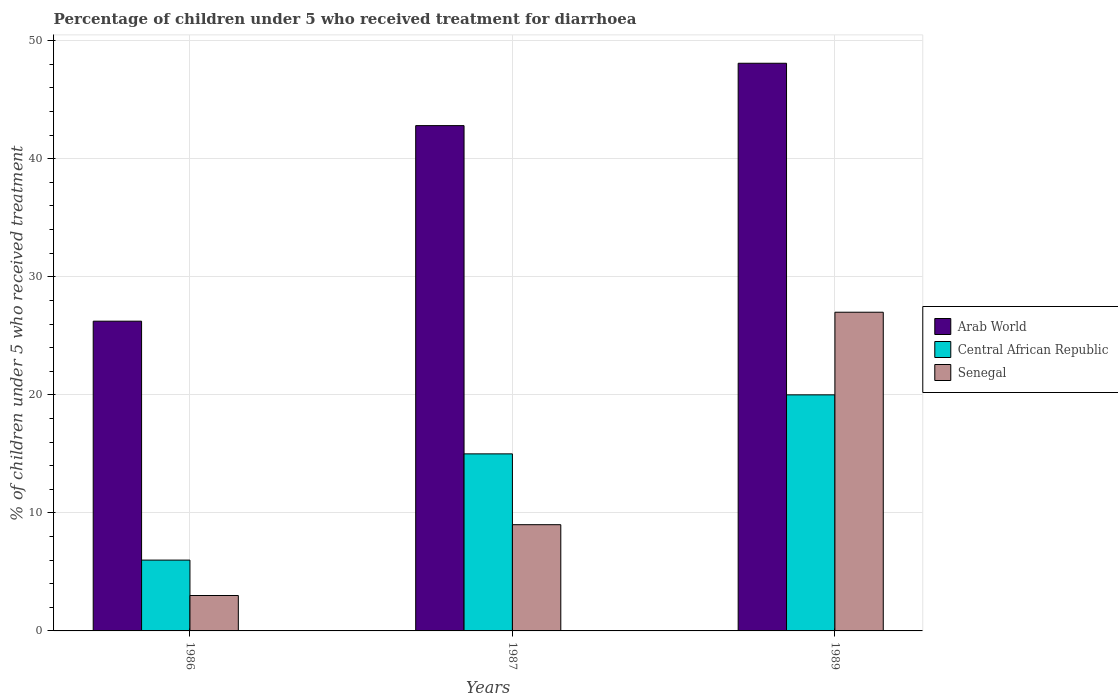How many groups of bars are there?
Offer a very short reply. 3. Are the number of bars per tick equal to the number of legend labels?
Your answer should be very brief. Yes. How many bars are there on the 3rd tick from the right?
Keep it short and to the point. 3. In how many cases, is the number of bars for a given year not equal to the number of legend labels?
Make the answer very short. 0. Across all years, what is the maximum percentage of children who received treatment for diarrhoea  in Central African Republic?
Provide a succinct answer. 20. Across all years, what is the minimum percentage of children who received treatment for diarrhoea  in Senegal?
Provide a succinct answer. 3. In which year was the percentage of children who received treatment for diarrhoea  in Central African Republic minimum?
Keep it short and to the point. 1986. What is the total percentage of children who received treatment for diarrhoea  in Arab World in the graph?
Provide a short and direct response. 117.14. What is the difference between the percentage of children who received treatment for diarrhoea  in Arab World in 1986 and the percentage of children who received treatment for diarrhoea  in Senegal in 1987?
Make the answer very short. 17.24. In the year 1989, what is the difference between the percentage of children who received treatment for diarrhoea  in Central African Republic and percentage of children who received treatment for diarrhoea  in Arab World?
Provide a succinct answer. -28.09. What is the ratio of the percentage of children who received treatment for diarrhoea  in Arab World in 1986 to that in 1987?
Your answer should be very brief. 0.61. Is the percentage of children who received treatment for diarrhoea  in Senegal in 1986 less than that in 1987?
Make the answer very short. Yes. What is the difference between the highest and the lowest percentage of children who received treatment for diarrhoea  in Senegal?
Your response must be concise. 24. Is the sum of the percentage of children who received treatment for diarrhoea  in Central African Republic in 1986 and 1989 greater than the maximum percentage of children who received treatment for diarrhoea  in Senegal across all years?
Provide a succinct answer. No. What does the 3rd bar from the left in 1987 represents?
Ensure brevity in your answer.  Senegal. What does the 2nd bar from the right in 1986 represents?
Make the answer very short. Central African Republic. Is it the case that in every year, the sum of the percentage of children who received treatment for diarrhoea  in Central African Republic and percentage of children who received treatment for diarrhoea  in Senegal is greater than the percentage of children who received treatment for diarrhoea  in Arab World?
Make the answer very short. No. How many bars are there?
Keep it short and to the point. 9. Are all the bars in the graph horizontal?
Provide a succinct answer. No. Are the values on the major ticks of Y-axis written in scientific E-notation?
Ensure brevity in your answer.  No. Does the graph contain grids?
Provide a succinct answer. Yes. Where does the legend appear in the graph?
Offer a terse response. Center right. How many legend labels are there?
Keep it short and to the point. 3. What is the title of the graph?
Offer a very short reply. Percentage of children under 5 who received treatment for diarrhoea. Does "Rwanda" appear as one of the legend labels in the graph?
Make the answer very short. No. What is the label or title of the Y-axis?
Offer a very short reply. % of children under 5 who received treatment. What is the % of children under 5 who received treatment of Arab World in 1986?
Offer a very short reply. 26.24. What is the % of children under 5 who received treatment of Arab World in 1987?
Provide a succinct answer. 42.81. What is the % of children under 5 who received treatment of Arab World in 1989?
Make the answer very short. 48.09. Across all years, what is the maximum % of children under 5 who received treatment in Arab World?
Offer a very short reply. 48.09. Across all years, what is the maximum % of children under 5 who received treatment in Central African Republic?
Give a very brief answer. 20. Across all years, what is the minimum % of children under 5 who received treatment of Arab World?
Give a very brief answer. 26.24. What is the total % of children under 5 who received treatment in Arab World in the graph?
Make the answer very short. 117.14. What is the total % of children under 5 who received treatment in Central African Republic in the graph?
Your response must be concise. 41. What is the difference between the % of children under 5 who received treatment in Arab World in 1986 and that in 1987?
Provide a succinct answer. -16.57. What is the difference between the % of children under 5 who received treatment in Senegal in 1986 and that in 1987?
Provide a short and direct response. -6. What is the difference between the % of children under 5 who received treatment of Arab World in 1986 and that in 1989?
Your answer should be compact. -21.85. What is the difference between the % of children under 5 who received treatment in Senegal in 1986 and that in 1989?
Keep it short and to the point. -24. What is the difference between the % of children under 5 who received treatment in Arab World in 1987 and that in 1989?
Your response must be concise. -5.28. What is the difference between the % of children under 5 who received treatment of Arab World in 1986 and the % of children under 5 who received treatment of Central African Republic in 1987?
Your answer should be compact. 11.24. What is the difference between the % of children under 5 who received treatment of Arab World in 1986 and the % of children under 5 who received treatment of Senegal in 1987?
Ensure brevity in your answer.  17.24. What is the difference between the % of children under 5 who received treatment in Arab World in 1986 and the % of children under 5 who received treatment in Central African Republic in 1989?
Your answer should be very brief. 6.24. What is the difference between the % of children under 5 who received treatment of Arab World in 1986 and the % of children under 5 who received treatment of Senegal in 1989?
Your answer should be compact. -0.76. What is the difference between the % of children under 5 who received treatment in Central African Republic in 1986 and the % of children under 5 who received treatment in Senegal in 1989?
Your answer should be very brief. -21. What is the difference between the % of children under 5 who received treatment in Arab World in 1987 and the % of children under 5 who received treatment in Central African Republic in 1989?
Offer a very short reply. 22.81. What is the difference between the % of children under 5 who received treatment in Arab World in 1987 and the % of children under 5 who received treatment in Senegal in 1989?
Your answer should be compact. 15.81. What is the average % of children under 5 who received treatment in Arab World per year?
Your answer should be very brief. 39.05. What is the average % of children under 5 who received treatment of Central African Republic per year?
Your response must be concise. 13.67. In the year 1986, what is the difference between the % of children under 5 who received treatment of Arab World and % of children under 5 who received treatment of Central African Republic?
Offer a very short reply. 20.24. In the year 1986, what is the difference between the % of children under 5 who received treatment of Arab World and % of children under 5 who received treatment of Senegal?
Your answer should be very brief. 23.24. In the year 1986, what is the difference between the % of children under 5 who received treatment in Central African Republic and % of children under 5 who received treatment in Senegal?
Ensure brevity in your answer.  3. In the year 1987, what is the difference between the % of children under 5 who received treatment in Arab World and % of children under 5 who received treatment in Central African Republic?
Offer a very short reply. 27.81. In the year 1987, what is the difference between the % of children under 5 who received treatment of Arab World and % of children under 5 who received treatment of Senegal?
Your answer should be very brief. 33.81. In the year 1987, what is the difference between the % of children under 5 who received treatment of Central African Republic and % of children under 5 who received treatment of Senegal?
Your answer should be compact. 6. In the year 1989, what is the difference between the % of children under 5 who received treatment of Arab World and % of children under 5 who received treatment of Central African Republic?
Your response must be concise. 28.09. In the year 1989, what is the difference between the % of children under 5 who received treatment of Arab World and % of children under 5 who received treatment of Senegal?
Ensure brevity in your answer.  21.09. In the year 1989, what is the difference between the % of children under 5 who received treatment in Central African Republic and % of children under 5 who received treatment in Senegal?
Ensure brevity in your answer.  -7. What is the ratio of the % of children under 5 who received treatment of Arab World in 1986 to that in 1987?
Make the answer very short. 0.61. What is the ratio of the % of children under 5 who received treatment of Senegal in 1986 to that in 1987?
Offer a very short reply. 0.33. What is the ratio of the % of children under 5 who received treatment in Arab World in 1986 to that in 1989?
Your response must be concise. 0.55. What is the ratio of the % of children under 5 who received treatment in Central African Republic in 1986 to that in 1989?
Offer a terse response. 0.3. What is the ratio of the % of children under 5 who received treatment in Arab World in 1987 to that in 1989?
Offer a terse response. 0.89. What is the difference between the highest and the second highest % of children under 5 who received treatment in Arab World?
Provide a succinct answer. 5.28. What is the difference between the highest and the lowest % of children under 5 who received treatment in Arab World?
Make the answer very short. 21.85. What is the difference between the highest and the lowest % of children under 5 who received treatment of Central African Republic?
Your response must be concise. 14. 